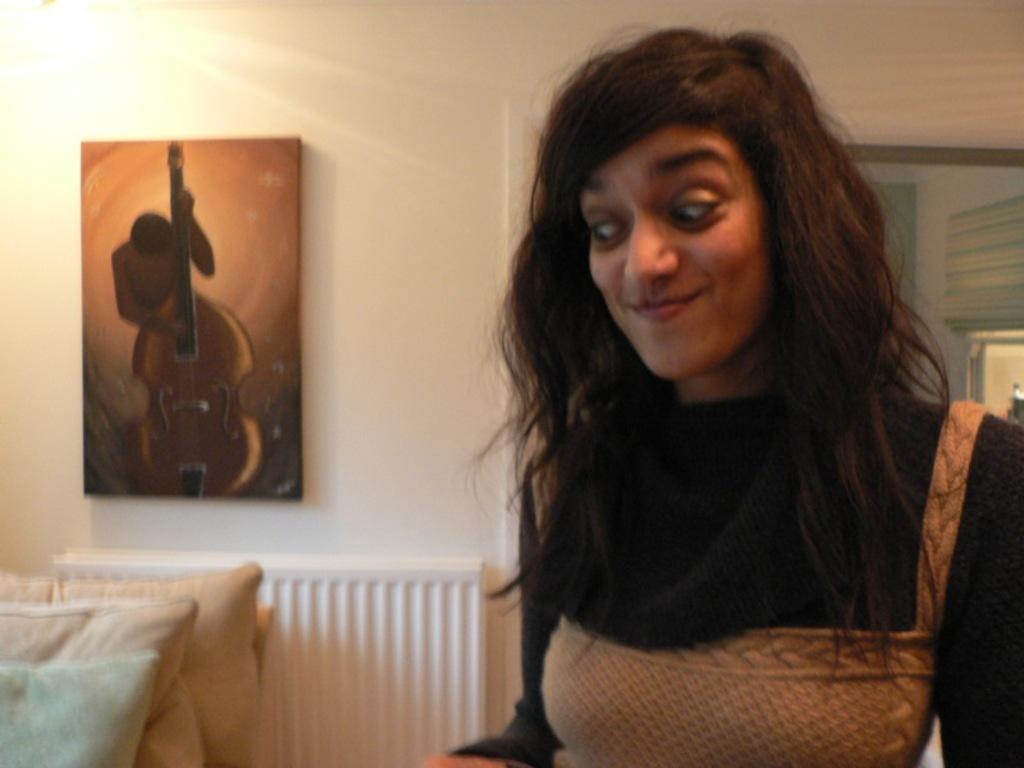Who is the main subject in the image? There is a lady in the image. What is the lady wearing? The lady is wearing a black and brown color dress. What is the lady's facial expression? The lady is smiling. What direction is the lady looking in? The lady is looking down. What architectural features can be seen on the left side of the image? There are three pillars on the left side of the image. What is present on the wall in the image? There is a frame on the wall in the image. How many dogs are visible in the image? There are no dogs present in the image. What type of underwear is the lady wearing in the image? The lady's clothing is described as a black and brown color dress, but there is no mention of underwear in the image. 